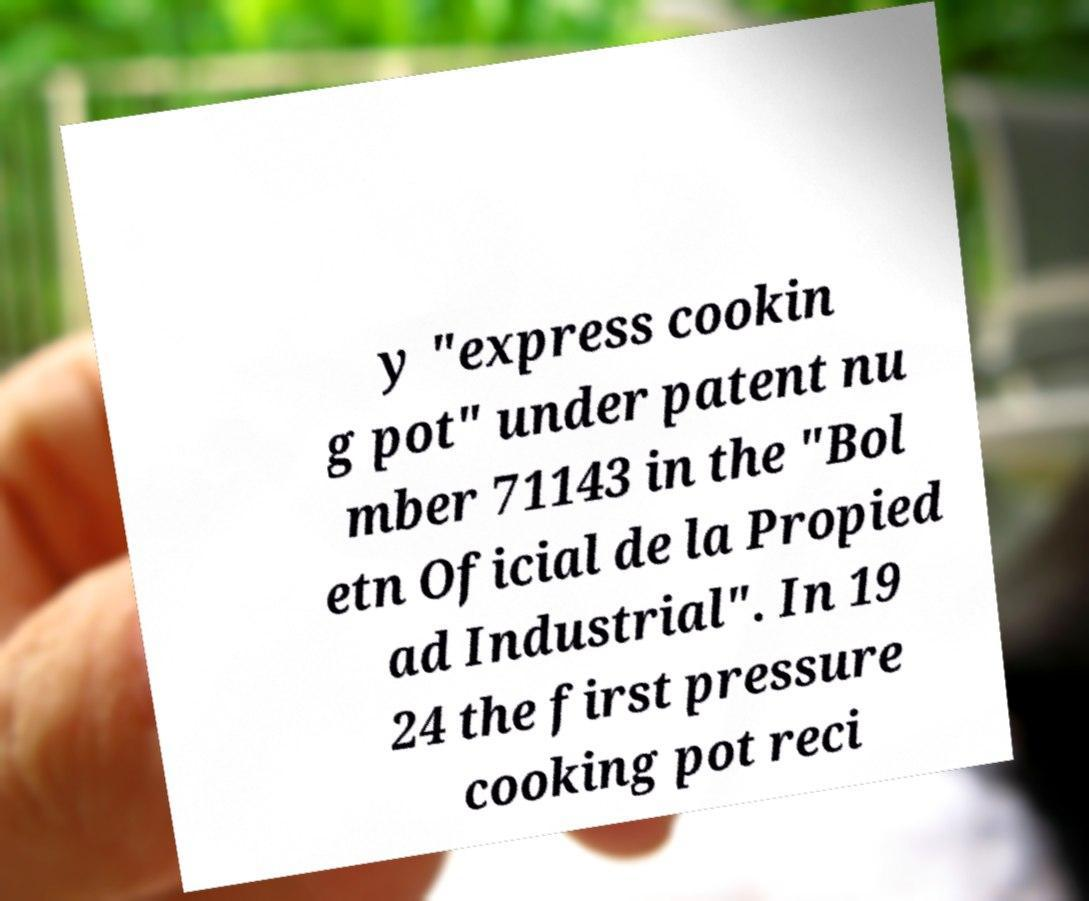There's text embedded in this image that I need extracted. Can you transcribe it verbatim? y "express cookin g pot" under patent nu mber 71143 in the "Bol etn Oficial de la Propied ad Industrial". In 19 24 the first pressure cooking pot reci 